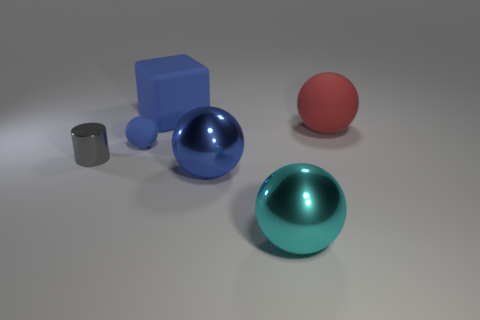Is the color of the big sphere behind the cylinder the same as the matte cube?
Your response must be concise. No. Are there more tiny matte spheres that are right of the big blue sphere than things that are left of the small blue matte ball?
Keep it short and to the point. No. Are there any other things that are the same color as the big rubber ball?
Make the answer very short. No. What number of objects are either gray metallic things or tiny red spheres?
Ensure brevity in your answer.  1. There is a thing that is right of the cyan metal ball; does it have the same size as the big cyan sphere?
Ensure brevity in your answer.  Yes. What number of other objects are there of the same size as the cyan ball?
Provide a succinct answer. 3. Is there a purple cube?
Make the answer very short. No. What is the size of the blue sphere in front of the small cylinder left of the tiny blue rubber ball?
Give a very brief answer. Large. There is a large block that is behind the gray shiny object; is its color the same as the rubber object to the right of the big blue rubber thing?
Keep it short and to the point. No. There is a large thing that is in front of the red thing and on the left side of the big cyan ball; what color is it?
Make the answer very short. Blue. 